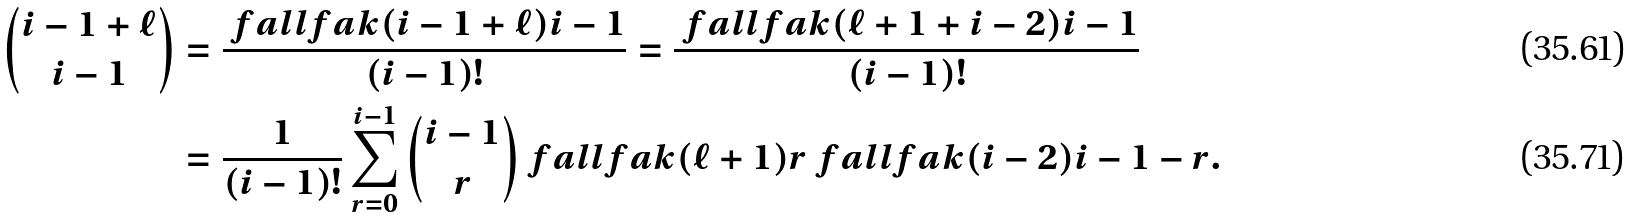<formula> <loc_0><loc_0><loc_500><loc_500>\binom { i - 1 + \ell } { i - 1 } & = \frac { \ f a l l f a k { ( i - 1 + \ell ) } { i - 1 } } { ( i - 1 ) ! } = \frac { \ f a l l f a k { ( \ell + 1 + i - 2 ) } { i - 1 } } { ( i - 1 ) ! } \\ & = \frac { 1 } { ( i - 1 ) ! } \sum _ { r = 0 } ^ { i - 1 } \binom { i - 1 } { r } \ f a l l f a k { ( \ell + 1 ) } { r } \ f a l l f a k { ( i - 2 ) } { i - 1 - r } .</formula> 